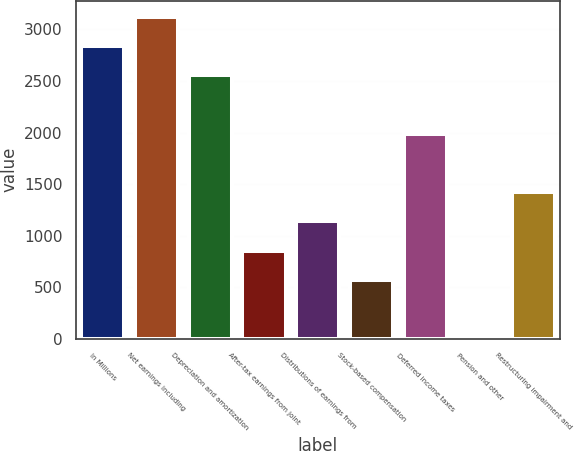Convert chart. <chart><loc_0><loc_0><loc_500><loc_500><bar_chart><fcel>In Millions<fcel>Net earnings including<fcel>Depreciation and amortization<fcel>After-tax earnings from joint<fcel>Distributions of earnings from<fcel>Stock-based compensation<fcel>Deferred income taxes<fcel>Pension and other<fcel>Restructuring impairment and<nl><fcel>2841<fcel>3124.64<fcel>2557.36<fcel>855.52<fcel>1139.16<fcel>571.88<fcel>1990.08<fcel>4.6<fcel>1422.8<nl></chart> 